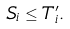<formula> <loc_0><loc_0><loc_500><loc_500>S _ { i } \leq T ^ { \prime } _ { i } .</formula> 